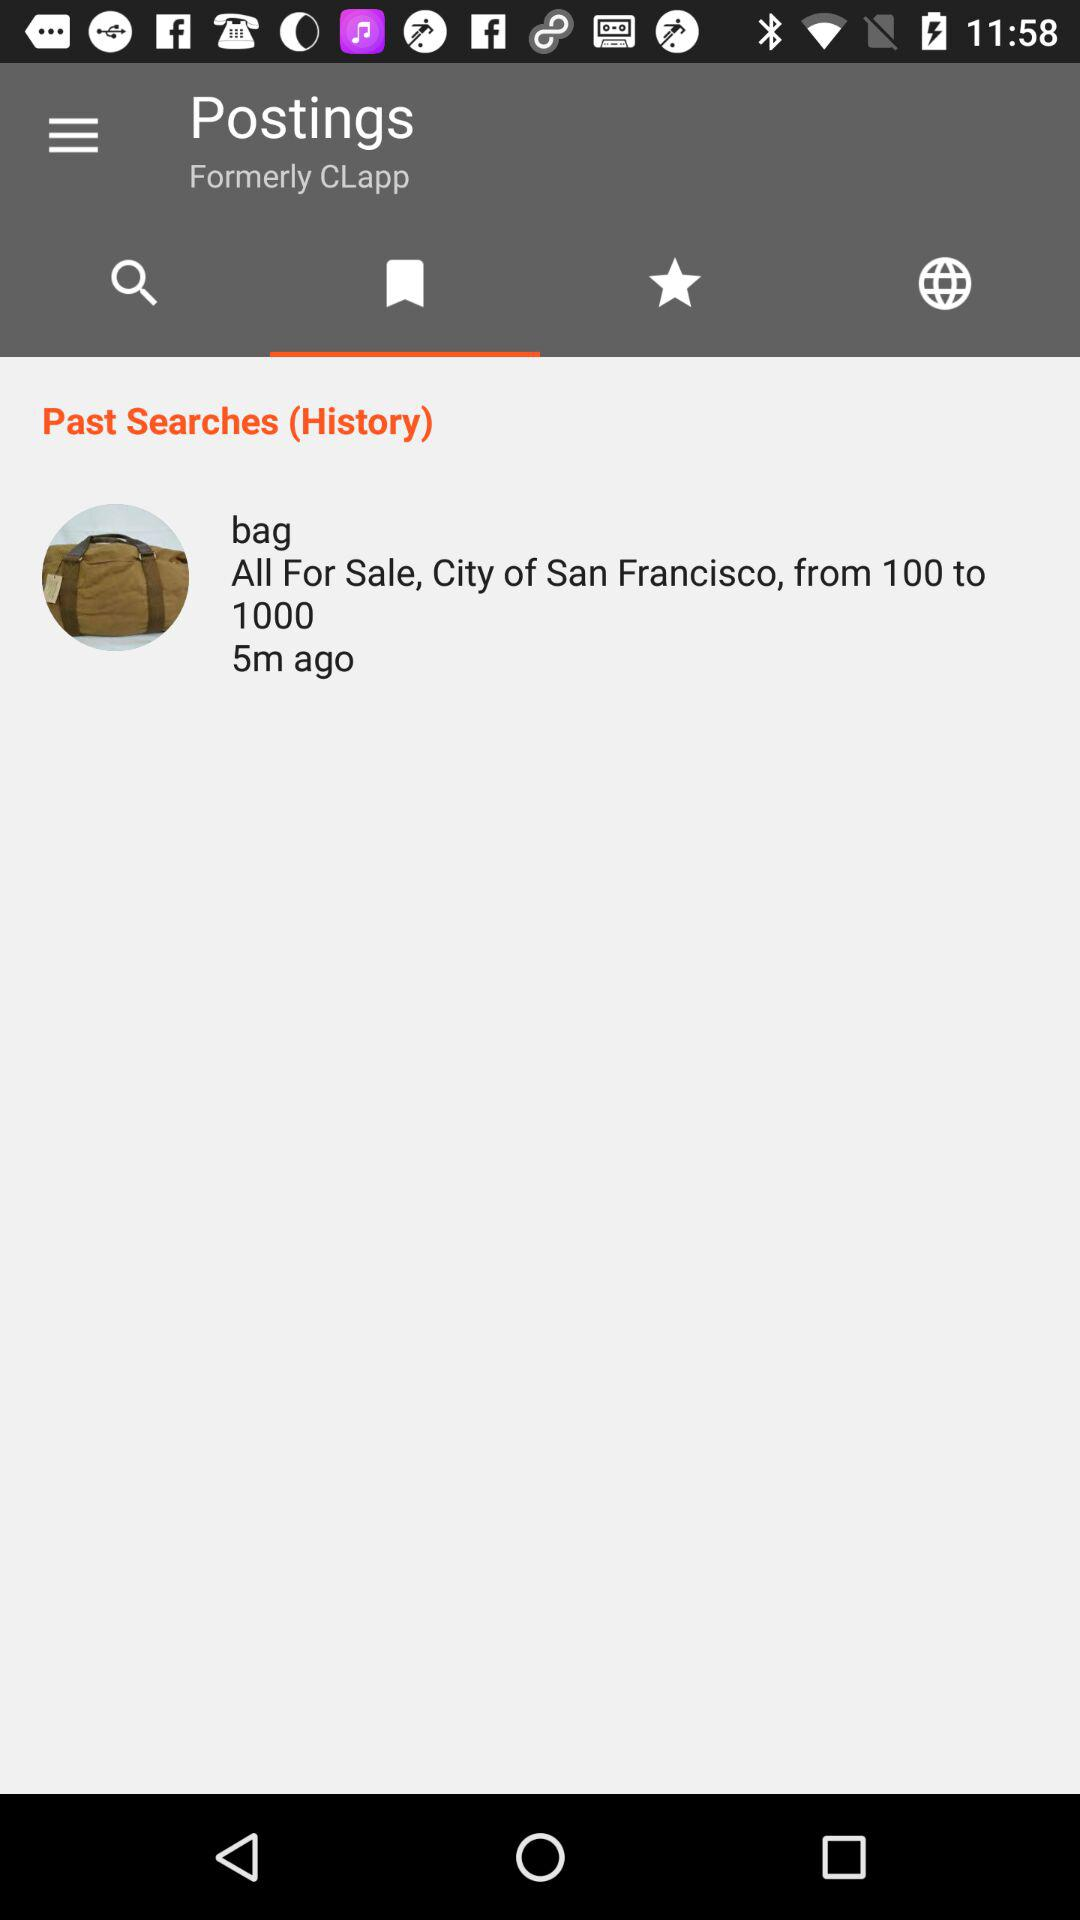Which tab is selected? The selected tab is "bookmark". 